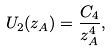<formula> <loc_0><loc_0><loc_500><loc_500>U _ { 2 } ( z _ { A } ) = \frac { C _ { 4 } } { z _ { A } ^ { 4 } } ,</formula> 